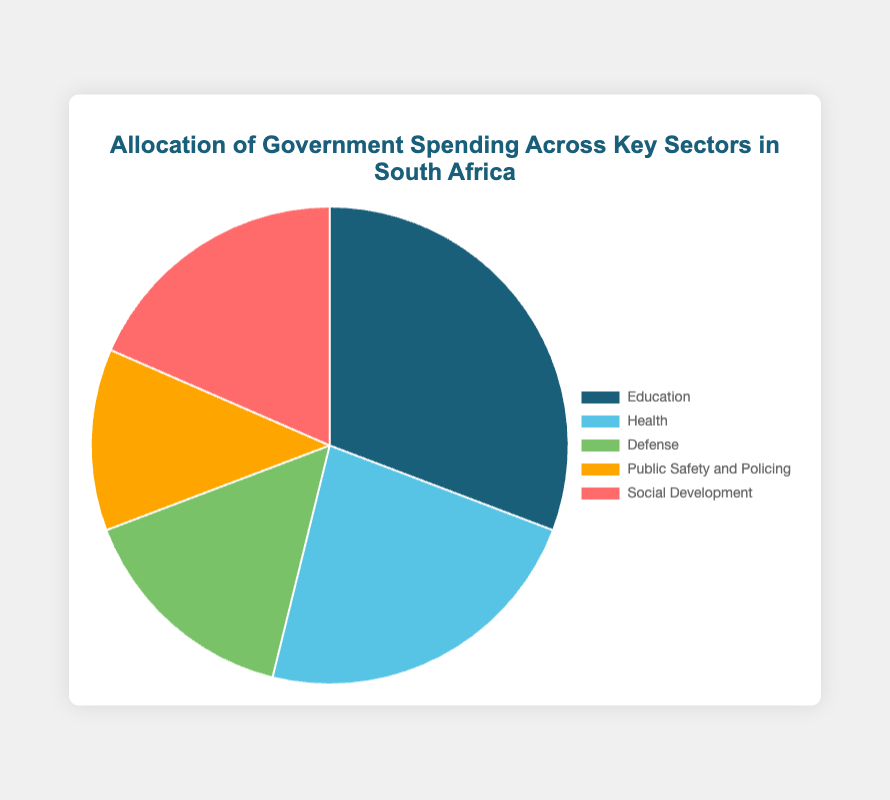Which sector receives the largest percentage of government spending? Education receives 20%, which is the highest among all sectors.
Answer: Education How much more percentage is allocated to Education compared to Health? Education receives 20%, and Health receives 15%. Subtract Health from Education (20% - 15%) to get 5%.
Answer: 5% Which sector receives the least percentage of government spending? Public Safety and Policing receives 8%, which is the least among all sectors.
Answer: Public Safety and Policing What is the total percentage of government spending allocated to Social Development and Economic Affairs combined? Social Development receives 12%, and Economic Affairs receives 18%. Add them up (12% + 18%) to get 30%.
Answer: 30% Is the percentage allocation for General Public Services greater than or less than that for Education? General Public Services receives 17%, and Education receives 20%. Since 17% is less than 20%, the allocation for General Public Services is less than that for Education.
Answer: Less than What is the average percentage allocation for Defense, Public Safety and Policing, and Social Development? Defense receives 10%, Public Safety and Policing receives 8%, and Social Development receives 12%. Sum them (10% + 8% + 12%) to get 30%. Since there are 3 sectors, divide 30% by 3 to get 10%.
Answer: 10% How does the spending on Economic Affairs compare to that on Health? Economic Affairs receives 18%, while Health receives 15%. Since 18% is greater than 15%, spending on Economic Affairs is greater than on Health.
Answer: Greater than Which sector is represented by the color blue in the pie chart? Education is represented by the color blue in the pie chart.
Answer: Education If the government decided to increase the percentage allocation for Public Safety and Policing to match that of Social Development, by how much percentage should it increase? Public Safety and Policing receives 8%, and Social Development receives 12%. Subtract Public Safety and Policing from Social Development (12% - 8%) to get 4%.
Answer: 4% Considering the top three sectors by spending, what percentage of the budget do they account for in total? The top three sectors are Education (20%), Economic Affairs (18%), and General Public Services (17%). Sum them up (20% + 18% + 17%) to get 55%.
Answer: 55% 